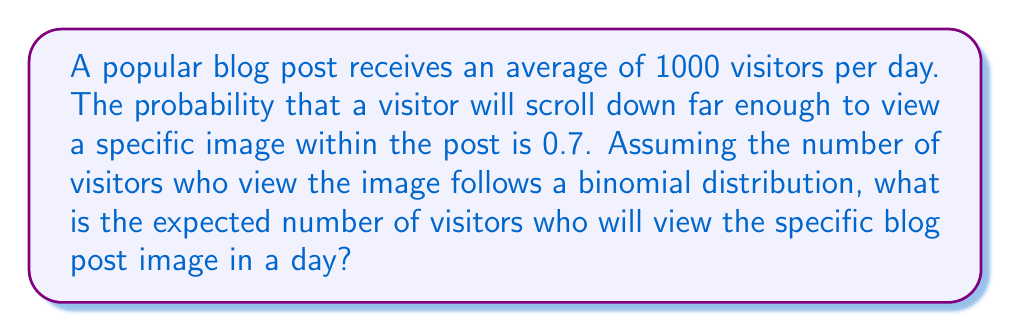Can you answer this question? To solve this problem, we need to use the concept of expected value for a binomial distribution.

1. Identify the parameters of the binomial distribution:
   - $n$ = number of trials (total visitors per day) = 1000
   - $p$ = probability of success (viewing the image) = 0.7

2. For a binomial distribution, the expected value is given by:
   $$E(X) = np$$

   Where:
   - $E(X)$ is the expected value
   - $n$ is the number of trials
   - $p$ is the probability of success

3. Substitute the values into the formula:
   $$E(X) = 1000 \times 0.7$$

4. Calculate the result:
   $$E(X) = 700$$

Therefore, the expected number of visitors who will view the specific blog post image in a day is 700.
Answer: The expected number of visitors who will view the specific blog post image in a day is 700. 